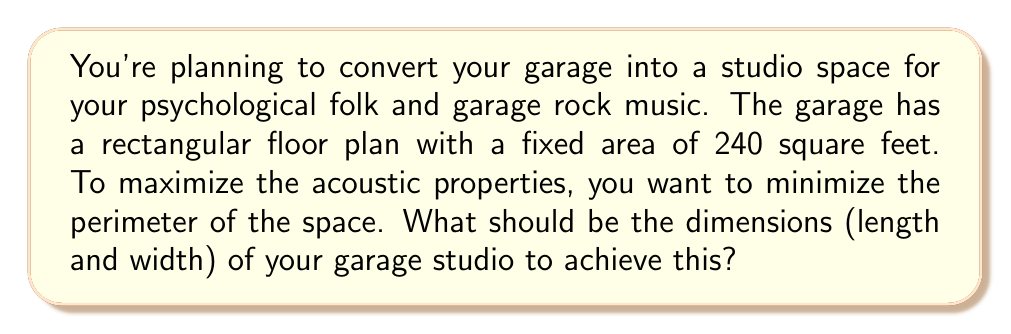Solve this math problem. Let's approach this step-by-step:

1) Let the width of the garage be $w$ and the length be $l$.

2) Given that the area is fixed at 240 square feet, we can write:
   $$A = w \cdot l = 240$$

3) We want to minimize the perimeter. The perimeter $P$ is given by:
   $$P = 2w + 2l$$

4) We can express $l$ in terms of $w$ using the area equation:
   $$l = \frac{240}{w}$$

5) Substituting this into the perimeter equation:
   $$P = 2w + 2(\frac{240}{w}) = 2w + \frac{480}{w}$$

6) To find the minimum value of $P$, we differentiate with respect to $w$ and set it to zero:
   $$\frac{dP}{dw} = 2 - \frac{480}{w^2} = 0$$

7) Solving this equation:
   $$2 = \frac{480}{w^2}$$
   $$w^2 = 240$$
   $$w = \sqrt{240} = 4\sqrt{15} \approx 15.49$$

8) Since $w \cdot l = 240$, $l$ must also equal $4\sqrt{15}$.

9) Therefore, the optimal dimensions are:
   Width = Length = $4\sqrt{15}$ feet ≈ 15.49 feet

This results in a square shape, which minimizes the perimeter for a given area.
Answer: $4\sqrt{15}$ feet × $4\sqrt{15}$ feet (approximately 15.49 feet × 15.49 feet) 